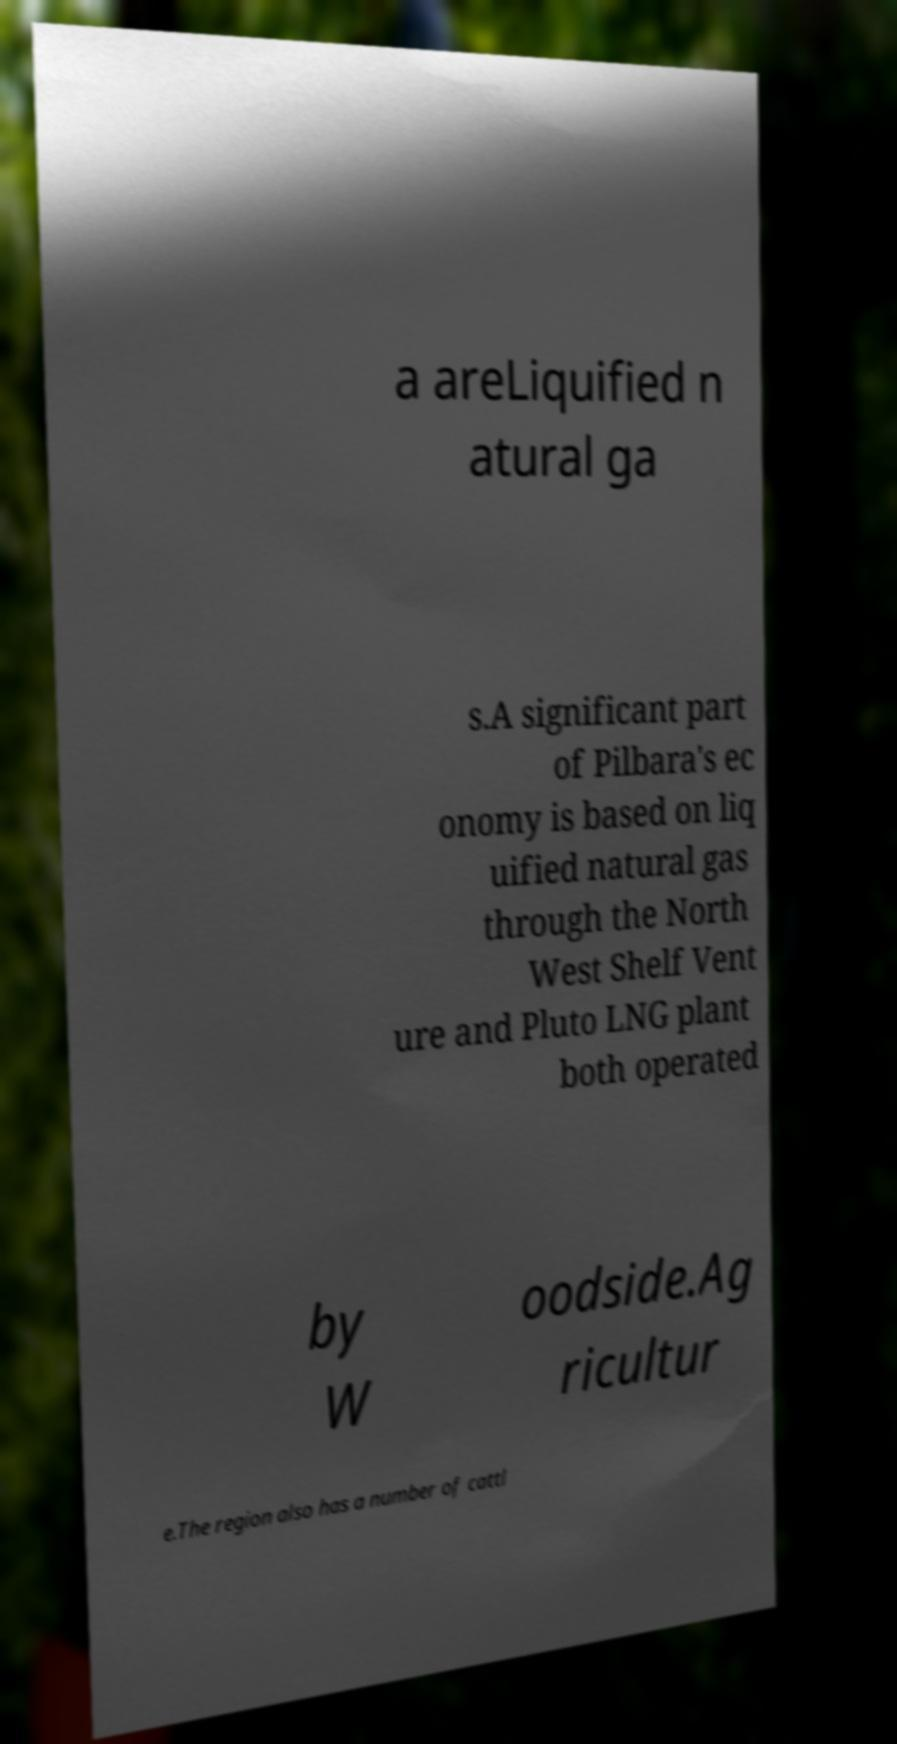Please identify and transcribe the text found in this image. a areLiquified n atural ga s.A significant part of Pilbara's ec onomy is based on liq uified natural gas through the North West Shelf Vent ure and Pluto LNG plant both operated by W oodside.Ag ricultur e.The region also has a number of cattl 